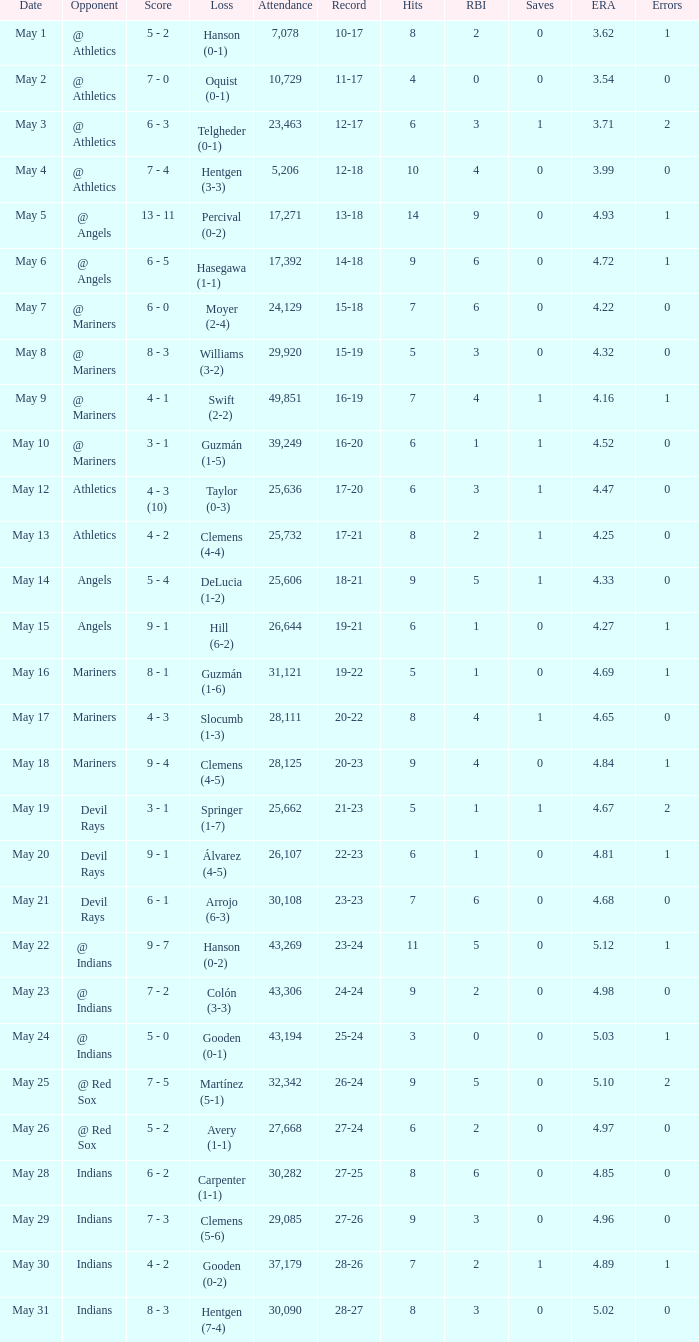When did the 27-25 record occur? May 28. 